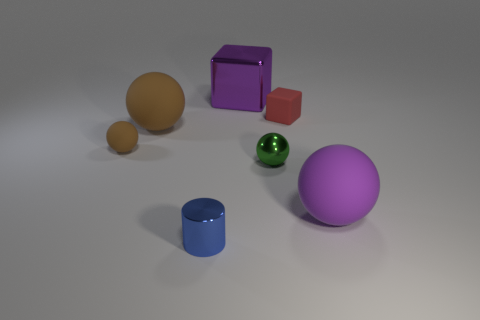Subtract all small shiny spheres. How many spheres are left? 3 Subtract all brown spheres. How many spheres are left? 2 Subtract all blocks. How many objects are left? 5 Subtract 1 balls. How many balls are left? 3 Add 3 tiny metallic cylinders. How many objects exist? 10 Subtract all purple balls. How many red blocks are left? 1 Subtract 0 yellow cubes. How many objects are left? 7 Subtract all brown cylinders. Subtract all red cubes. How many cylinders are left? 1 Subtract all tiny gray cubes. Subtract all big brown things. How many objects are left? 6 Add 3 small brown rubber spheres. How many small brown rubber spheres are left? 4 